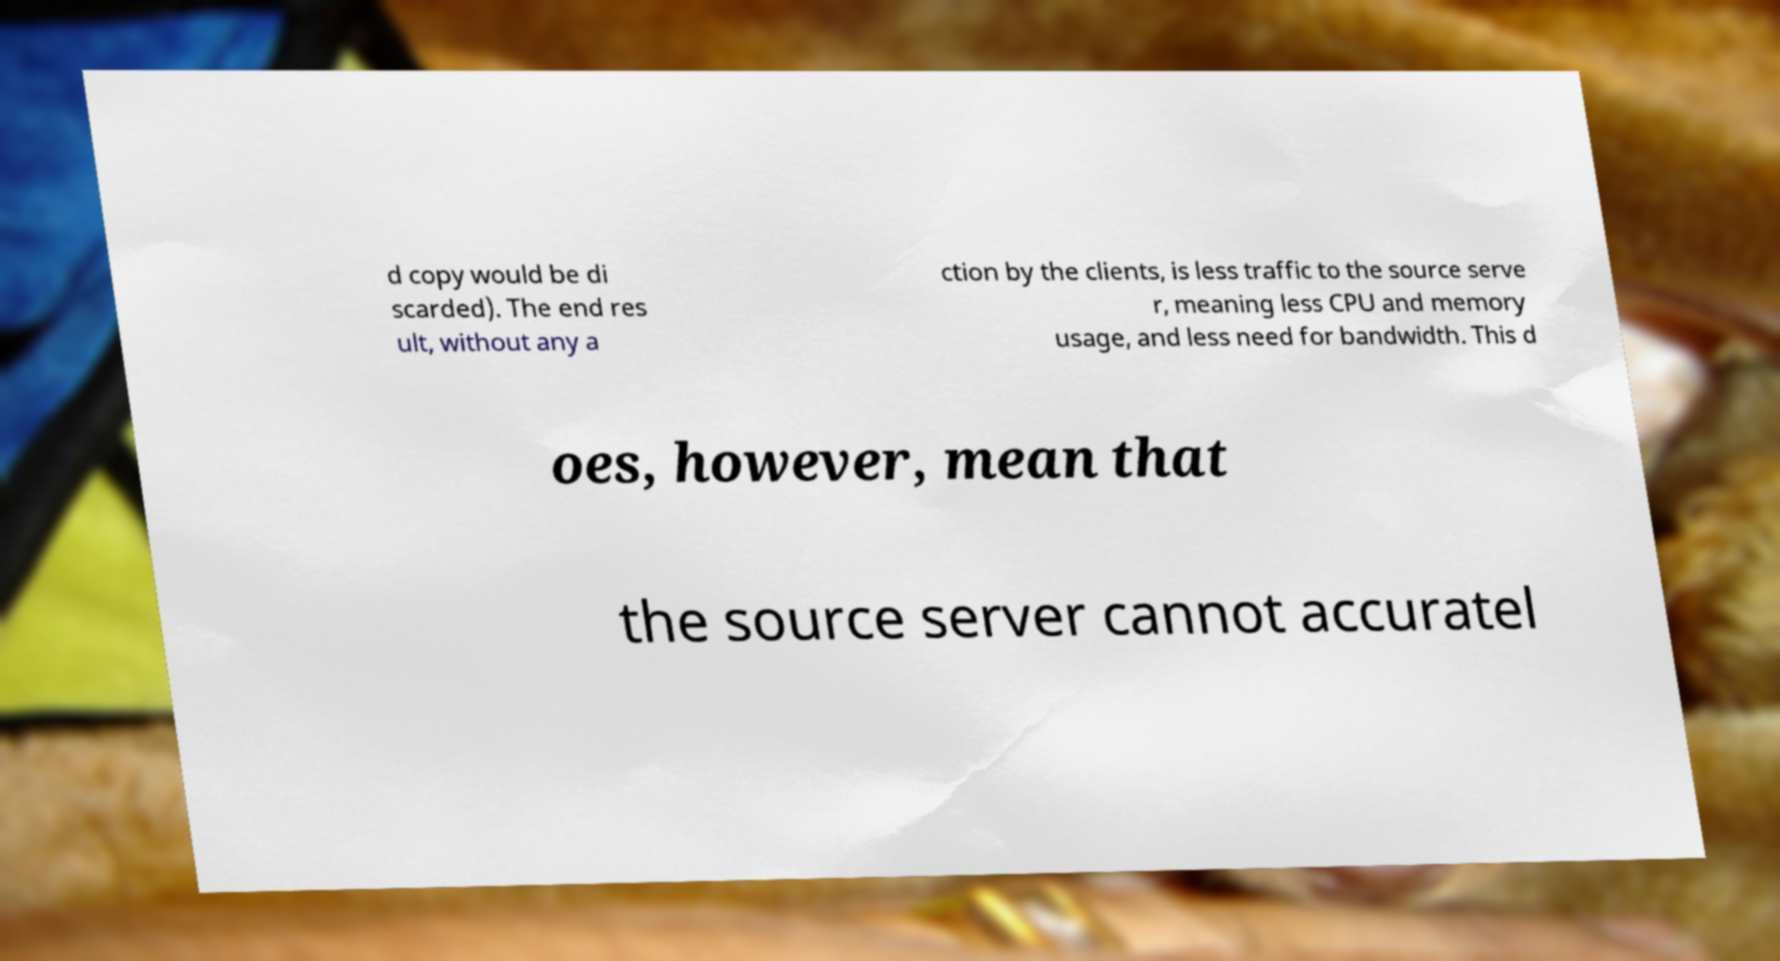Please read and relay the text visible in this image. What does it say? d copy would be di scarded). The end res ult, without any a ction by the clients, is less traffic to the source serve r, meaning less CPU and memory usage, and less need for bandwidth. This d oes, however, mean that the source server cannot accuratel 